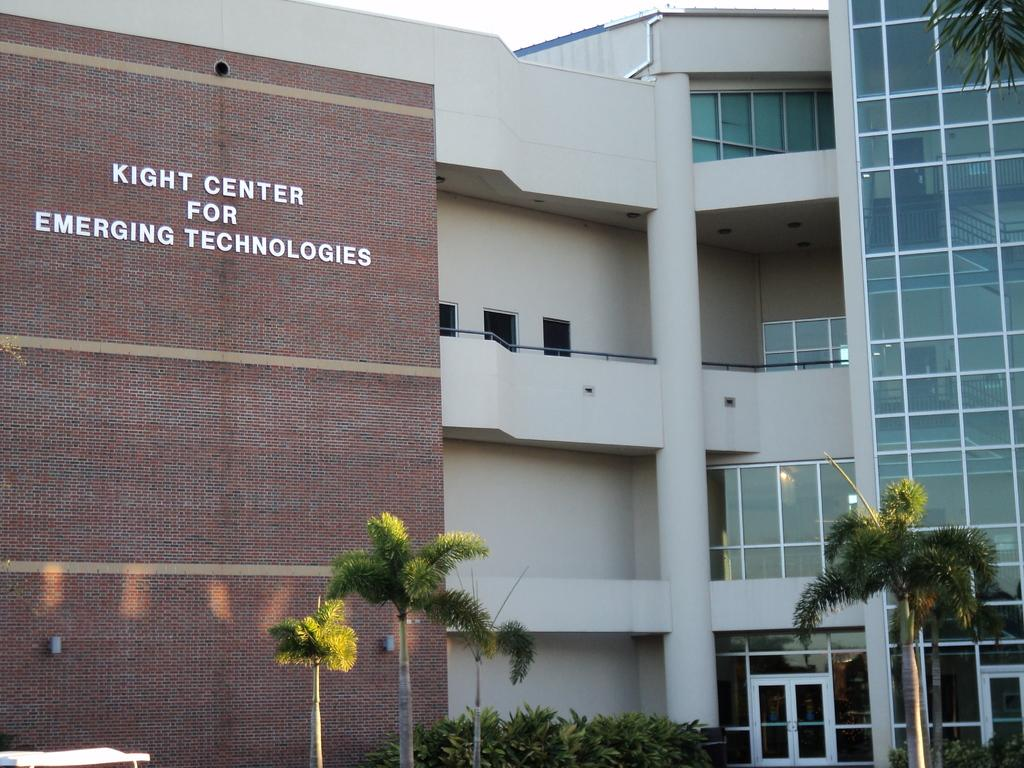What type of structure is present in the image? There is a building in the image. What is written or displayed on the building? There is text on the building. What type of vegetation can be seen in the image? There are trees and plants in the image. Can you describe the object located on the bottom left of the image? There is an object on the bottom left of the image, but its specific details are not mentioned in the facts. What is visible in the background of the image? The sky is visible in the image. What material is present in the image that might be transparent or reflective? There is some glass visible in the image. What type of apparel is the cat wearing in the image? There is no cat present in the image, and therefore no apparel can be observed. 